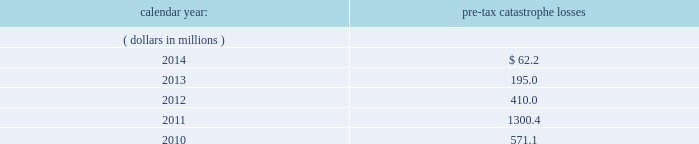Available information .
The company 2019s annual reports on form 10-k , quarterly reports on form 10-q , current reports on form 8- k , proxy statements and amendments to those reports are available free of charge through the company 2019s internet website at http://www.everestregroup.com as soon as reasonably practicable after such reports are electronically filed with the securities and exchange commission ( the 201csec 201d ) .
Item 1a .
Risk factors in addition to the other information provided in this report , the following risk factors should be considered when evaluating an investment in our securities .
If the circumstances contemplated by the individual risk factors materialize , our business , financial condition and results of operations could be materially and adversely affected and the trading price of our common shares could decline significantly .
Risks relating to our business fluctuations in the financial markets could result in investment losses .
Prolonged and severe disruptions in the overall public debt and equity markets , such as occurred during 2008 , could result in significant realized and unrealized losses in our investment portfolio .
Although financial markets have significantly improved since 2008 , they could deteriorate in the future .
There could also be disruption in individual market sectors , such as occurred in the energy sector during the fourth quarter of 2014 .
Such declines in the financial markets could result in significant realized and unrealized losses on investments and could have a material adverse impact on our results of operations , equity , business and insurer financial strength and debt ratings .
Our results could be adversely affected by catastrophic events .
We are exposed to unpredictable catastrophic events , including weather-related and other natural catastrophes , as well as acts of terrorism .
Any material reduction in our operating results caused by the occurrence of one or more catastrophes could inhibit our ability to pay dividends or to meet our interest and principal payment obligations .
Subsequent to april 1 , 2010 , we define a catastrophe as an event that causes a loss on property exposures before reinsurance of at least $ 10.0 million , before corporate level reinsurance and taxes .
Prior to april 1 , 2010 , we used a threshold of $ 5.0 million .
By way of illustration , during the past five calendar years , pre-tax catastrophe losses , net of contract specific reinsurance but before cessions under corporate reinsurance programs , were as follows: .
Our losses from future catastrophic events could exceed our projections .
We use projections of possible losses from future catastrophic events of varying types and magnitudes as a strategic underwriting tool .
We use these loss projections to estimate our potential catastrophe losses in certain geographic areas and decide on the placement of retrocessional coverage or other actions to limit the extent of potential losses in a given geographic area .
These loss projections are approximations , reliant on a mix of quantitative and qualitative processes , and actual losses may exceed the projections by a material amount , resulting in a material adverse effect on our financial condition and results of operations. .
What are the total pre-tax catastrophe losses in the last 2 years?\\n? 
Computations: (62.2 + 195.0)
Answer: 257.2. 